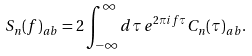<formula> <loc_0><loc_0><loc_500><loc_500>S _ { n } ( f ) _ { a b } = 2 \int _ { - \infty } ^ { \infty } d \tau \, e ^ { 2 \pi i f \tau } C _ { n } ( \tau ) _ { a b } .</formula> 